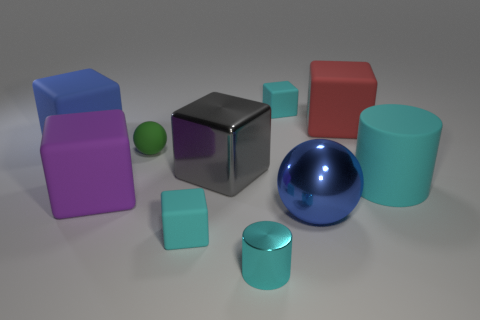What number of cyan things are the same size as the green thing?
Your answer should be compact. 3. Are any cyan cylinders visible?
Keep it short and to the point. Yes. Is there any other thing of the same color as the small cylinder?
Your answer should be compact. Yes. What is the shape of the big cyan object that is made of the same material as the blue block?
Offer a very short reply. Cylinder. There is a small block that is behind the tiny cyan rubber thing that is on the left side of the cyan object behind the red block; what is its color?
Offer a terse response. Cyan. Are there an equal number of large purple things that are on the left side of the tiny cylinder and metal spheres?
Offer a terse response. Yes. Are there any other things that are the same material as the blue block?
Your answer should be very brief. Yes. Is the color of the large shiny cube the same as the metal cylinder that is on the left side of the big matte cylinder?
Give a very brief answer. No. Are there any green balls in front of the small thing to the left of the tiny rubber thing that is in front of the large gray cube?
Your answer should be compact. No. Are there fewer small metal cylinders right of the red thing than big purple matte cubes?
Offer a terse response. Yes. 